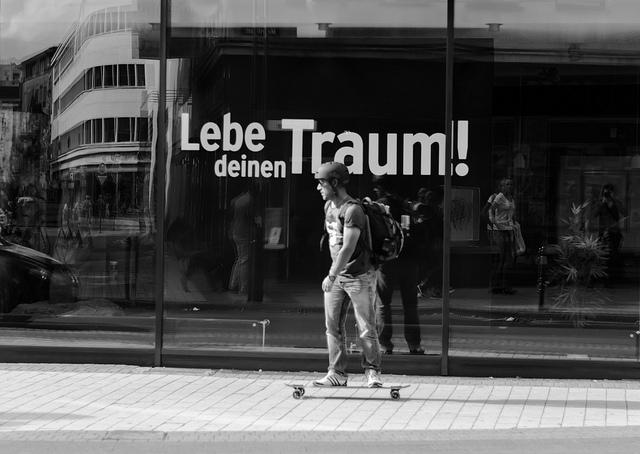What time of day is it likely to be? Please explain your reasoning. afternoon. Based on the shadows it looks like the sun is high in the sky, which would make it afternoon. 